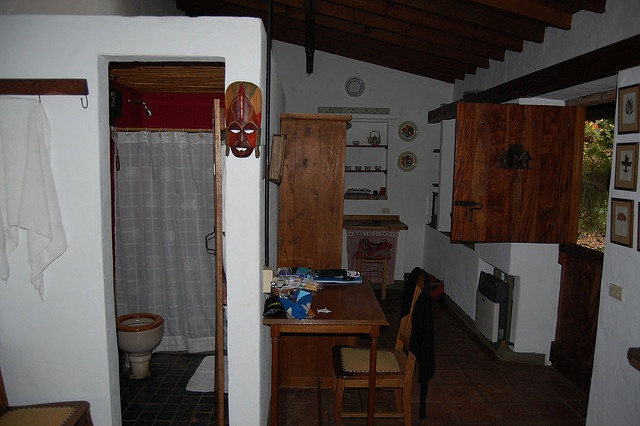Describe the objects in this image and their specific colors. I can see chair in gray, black, and maroon tones, dining table in gray, black, and maroon tones, toilet in gray and black tones, chair in gray, black, and maroon tones, and handbag in black and gray tones in this image. 